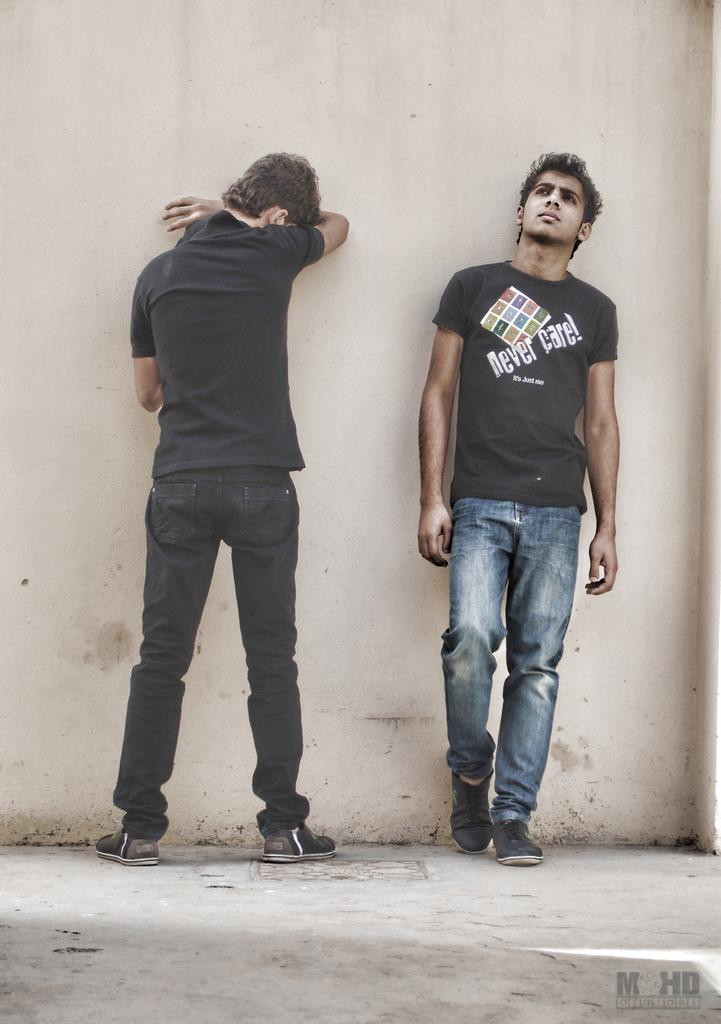How many people are in the image? There are two men standing in the center of the image. What is the background of the image? There is a wall at the top of the image. What is the foreground of the image? There is a floor at the bottom of the image. What type of appliance is being used by the men in the image? There is no appliance visible in the image; the image only shows two men standing in the center of the image with a wall at the top and a floor at the bottom. 